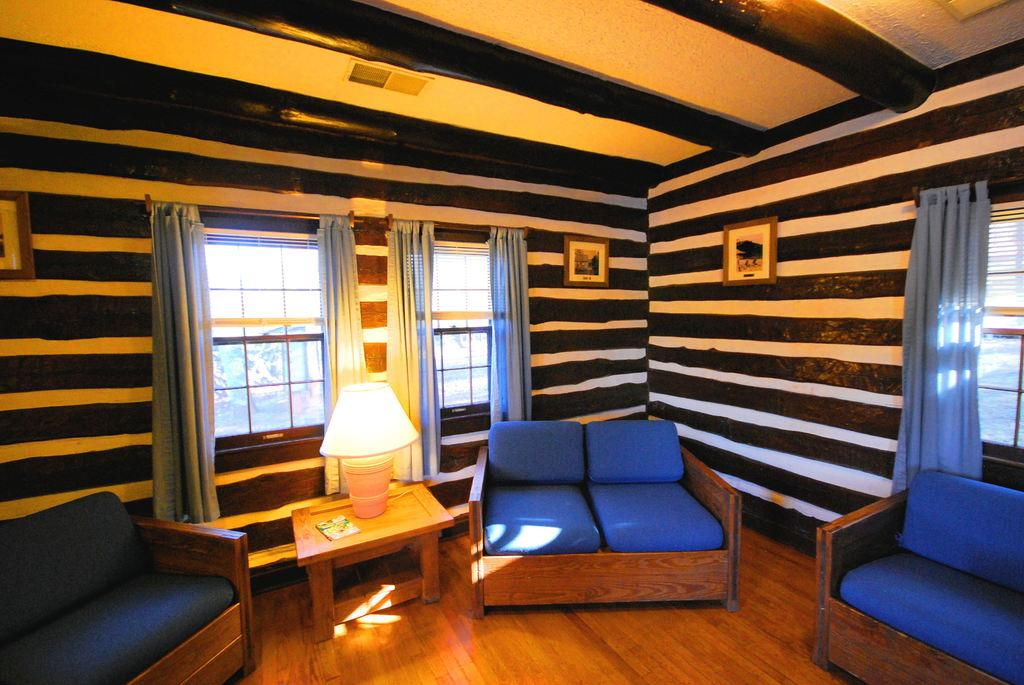What type of structure can be seen in the image? There is a wall in the image. Are there any openings in the wall? Yes, there are windows in the image. What type of lighting is present in the image? There is a lamp in the image. What type of furniture is in the image? There is a table and sofas in the image. What color are the sofas? The sofas are blue. What type of window treatment is present in the image? There is a sky blue curtain in the image. Are there any decorative items in the image? Yes, there are two photo frames in the image. What type of zinc is used to support the sofas in the image? There is no mention of zinc or any support structure for the sofas in the image. What type of beam is visible in the image? There is no beam visible in the image. 